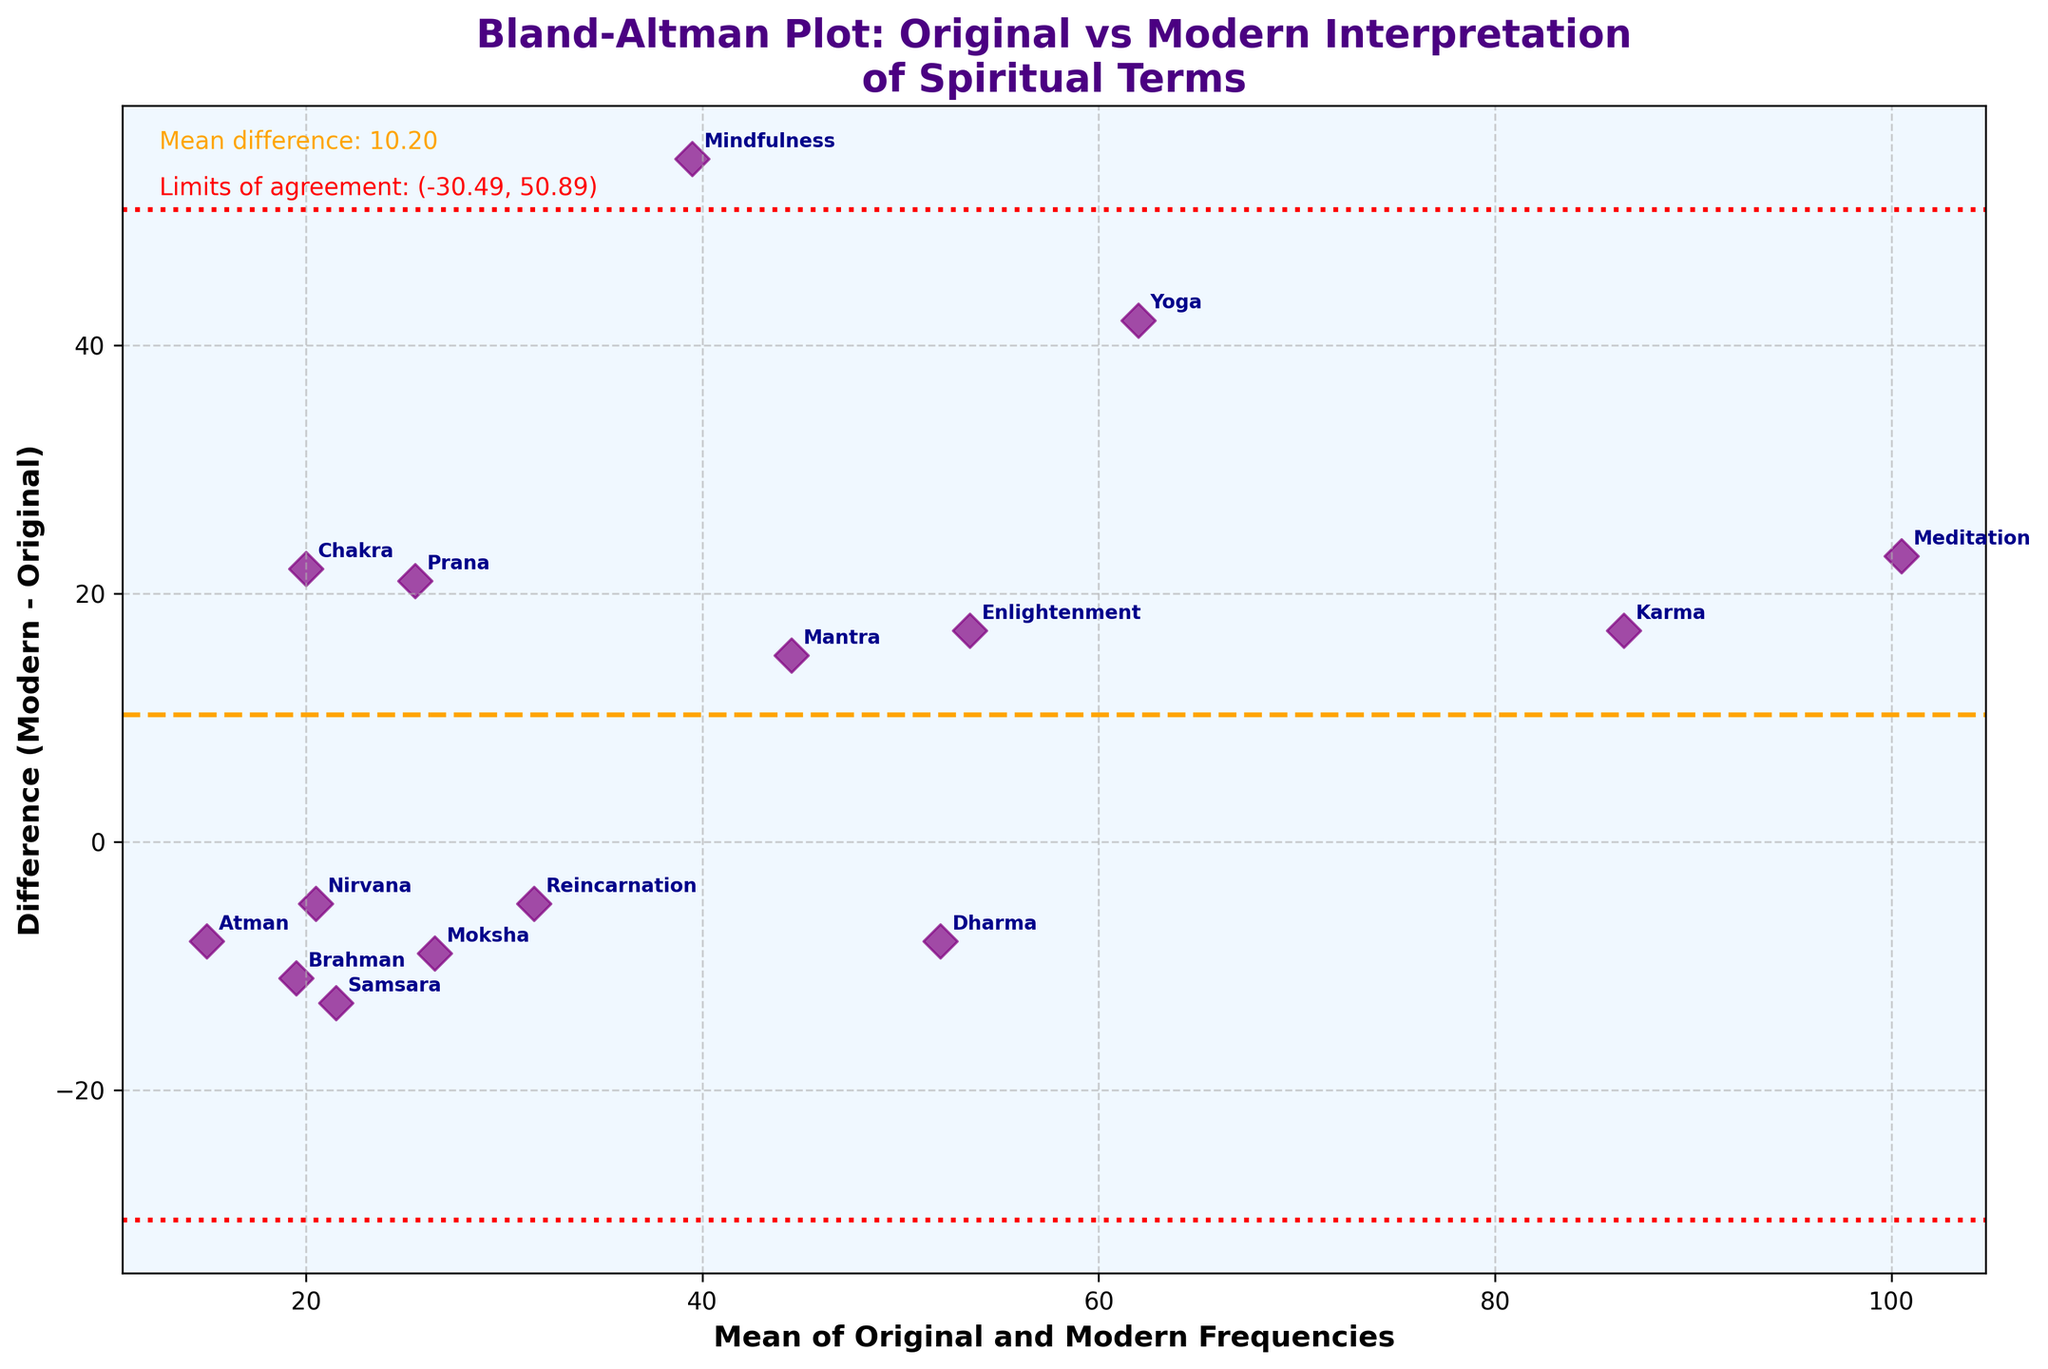What is the title of the figure? The title of the figure is usually found at the top of the plot. In this case, the title is "Bland-Altman Plot: Original vs Modern Interpretation of Spiritual Terms".
Answer: Bland-Altman Plot: Original vs Modern Interpretation of Spiritual Terms What do the red dashed lines represent? The red dashed lines typically represent the limits of agreement in a Bland-Altman plot, which indicate where most of the differences between the original and modern frequencies should lie.
Answer: Limits of agreement What is the mean difference between the original and modern frequencies? The mean difference is usually indicated by a horizontal line and annotated on the plot. In this case, it is given as "Mean difference: 12.67".
Answer: 12.67 Which term has the largest positive difference between modern and original frequencies? To find the term with the largest positive difference, look at the highest point on the y-axis where the difference (Modern - Original) is plotted. "Mindfulness" has the largest positive difference.
Answer: Mindfulness Which terms fall outside the limits of agreement? Terms outside the limits of agreement appear above or below the dashed red lines. "Yoga," "Mindfulness," "Chakra," and "Prana" fall outside these limits.
Answer: Yoga, Mindfulness, Chakra, Prana What is the difference in frequency for the term "Meditation"? Look for the annotation near the point representing "Meditation" on the plot. The difference is between the modern interpretation (112) and the original frequency (89), which is 112 - 89 = 23.
Answer: 23 What does the purple color in the scatter points represent? The color purple is used to plot the points representing the difference between modern and original frequencies for each term.
Answer: Difference points Is the term "Dharma" used more frequently in the modern interpretation or in the original? For "Dharma," the plot indicates it has a negative difference, meaning it is used less frequently in the modern interpretations than in the original (48 vs 56).
Answer: Original Which terms have a difference of zero between the original and modern frequencies? A difference of zero would mean those data points lie on the x-axis without any deviation above or below. No terms lie on this line, so none have a zero difference.
Answer: None What are the values for the limits of agreement? The plot annotates the values for the limits of agreement as approximately (mean difference ± 1.96 * standard deviation). They are listed as (-23.37, 48.71).
Answer: -23.37, 48.71 